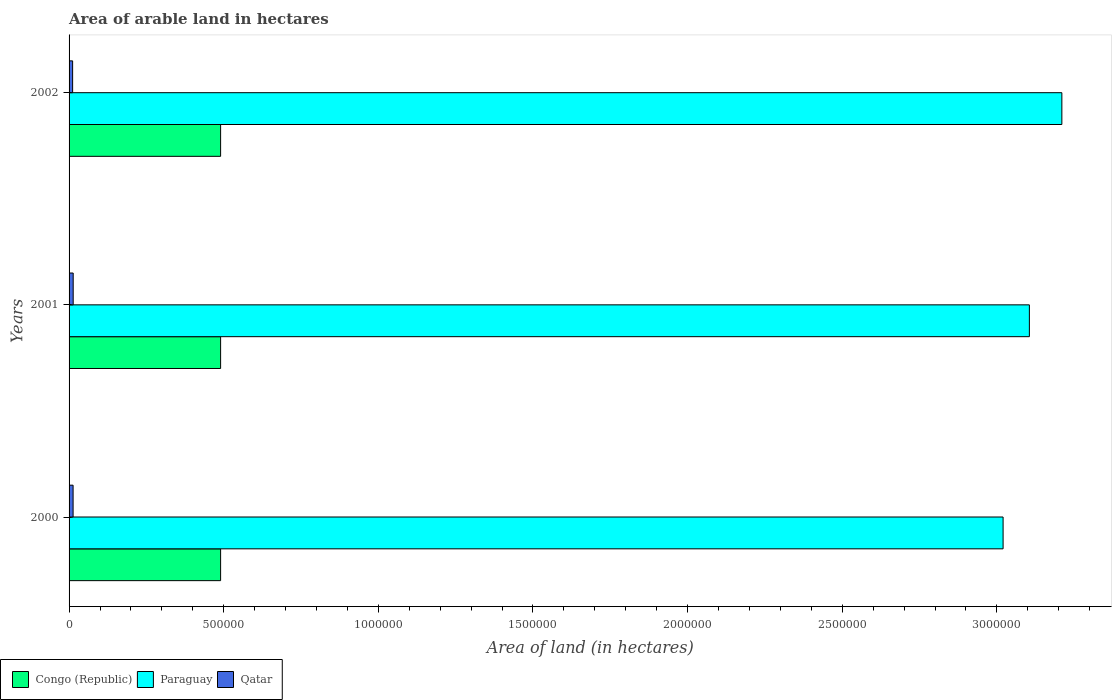How many bars are there on the 1st tick from the top?
Your response must be concise. 3. What is the total arable land in Qatar in 2001?
Ensure brevity in your answer.  1.33e+04. Across all years, what is the maximum total arable land in Paraguay?
Provide a succinct answer. 3.21e+06. Across all years, what is the minimum total arable land in Paraguay?
Your response must be concise. 3.02e+06. What is the total total arable land in Congo (Republic) in the graph?
Offer a terse response. 1.47e+06. What is the difference between the total arable land in Paraguay in 2000 and that in 2001?
Provide a short and direct response. -8.50e+04. What is the difference between the total arable land in Congo (Republic) in 2001 and the total arable land in Qatar in 2002?
Offer a very short reply. 4.78e+05. What is the average total arable land in Congo (Republic) per year?
Offer a terse response. 4.90e+05. In the year 2000, what is the difference between the total arable land in Paraguay and total arable land in Qatar?
Your answer should be compact. 3.01e+06. In how many years, is the total arable land in Congo (Republic) greater than 500000 hectares?
Your answer should be compact. 0. Is the total arable land in Paraguay in 2000 less than that in 2002?
Make the answer very short. Yes. Is the difference between the total arable land in Paraguay in 2001 and 2002 greater than the difference between the total arable land in Qatar in 2001 and 2002?
Keep it short and to the point. No. What is the difference between the highest and the second highest total arable land in Congo (Republic)?
Make the answer very short. 0. What is the difference between the highest and the lowest total arable land in Qatar?
Your answer should be very brief. 1800. Is the sum of the total arable land in Congo (Republic) in 2000 and 2001 greater than the maximum total arable land in Qatar across all years?
Give a very brief answer. Yes. What does the 1st bar from the top in 2000 represents?
Your answer should be compact. Qatar. What does the 2nd bar from the bottom in 2000 represents?
Your answer should be very brief. Paraguay. Is it the case that in every year, the sum of the total arable land in Congo (Republic) and total arable land in Qatar is greater than the total arable land in Paraguay?
Ensure brevity in your answer.  No. Does the graph contain any zero values?
Offer a terse response. No. How many legend labels are there?
Provide a short and direct response. 3. How are the legend labels stacked?
Make the answer very short. Horizontal. What is the title of the graph?
Give a very brief answer. Area of arable land in hectares. Does "Sub-Saharan Africa (developing only)" appear as one of the legend labels in the graph?
Offer a terse response. No. What is the label or title of the X-axis?
Provide a succinct answer. Area of land (in hectares). What is the label or title of the Y-axis?
Offer a very short reply. Years. What is the Area of land (in hectares) in Paraguay in 2000?
Provide a succinct answer. 3.02e+06. What is the Area of land (in hectares) in Qatar in 2000?
Ensure brevity in your answer.  1.30e+04. What is the Area of land (in hectares) of Congo (Republic) in 2001?
Ensure brevity in your answer.  4.90e+05. What is the Area of land (in hectares) of Paraguay in 2001?
Give a very brief answer. 3.10e+06. What is the Area of land (in hectares) in Qatar in 2001?
Your answer should be compact. 1.33e+04. What is the Area of land (in hectares) of Congo (Republic) in 2002?
Ensure brevity in your answer.  4.90e+05. What is the Area of land (in hectares) in Paraguay in 2002?
Ensure brevity in your answer.  3.21e+06. What is the Area of land (in hectares) of Qatar in 2002?
Offer a terse response. 1.15e+04. Across all years, what is the maximum Area of land (in hectares) of Congo (Republic)?
Offer a very short reply. 4.90e+05. Across all years, what is the maximum Area of land (in hectares) in Paraguay?
Offer a terse response. 3.21e+06. Across all years, what is the maximum Area of land (in hectares) of Qatar?
Offer a very short reply. 1.33e+04. Across all years, what is the minimum Area of land (in hectares) of Congo (Republic)?
Offer a very short reply. 4.90e+05. Across all years, what is the minimum Area of land (in hectares) in Paraguay?
Your answer should be compact. 3.02e+06. Across all years, what is the minimum Area of land (in hectares) in Qatar?
Your answer should be compact. 1.15e+04. What is the total Area of land (in hectares) in Congo (Republic) in the graph?
Provide a succinct answer. 1.47e+06. What is the total Area of land (in hectares) of Paraguay in the graph?
Keep it short and to the point. 9.34e+06. What is the total Area of land (in hectares) of Qatar in the graph?
Ensure brevity in your answer.  3.78e+04. What is the difference between the Area of land (in hectares) of Paraguay in 2000 and that in 2001?
Your answer should be compact. -8.50e+04. What is the difference between the Area of land (in hectares) in Qatar in 2000 and that in 2001?
Your response must be concise. -300. What is the difference between the Area of land (in hectares) of Congo (Republic) in 2000 and that in 2002?
Keep it short and to the point. 0. What is the difference between the Area of land (in hectares) of Paraguay in 2000 and that in 2002?
Your answer should be very brief. -1.90e+05. What is the difference between the Area of land (in hectares) of Qatar in 2000 and that in 2002?
Ensure brevity in your answer.  1500. What is the difference between the Area of land (in hectares) of Paraguay in 2001 and that in 2002?
Provide a succinct answer. -1.05e+05. What is the difference between the Area of land (in hectares) in Qatar in 2001 and that in 2002?
Your answer should be very brief. 1800. What is the difference between the Area of land (in hectares) in Congo (Republic) in 2000 and the Area of land (in hectares) in Paraguay in 2001?
Your answer should be very brief. -2.62e+06. What is the difference between the Area of land (in hectares) of Congo (Republic) in 2000 and the Area of land (in hectares) of Qatar in 2001?
Your answer should be very brief. 4.77e+05. What is the difference between the Area of land (in hectares) of Paraguay in 2000 and the Area of land (in hectares) of Qatar in 2001?
Provide a succinct answer. 3.01e+06. What is the difference between the Area of land (in hectares) of Congo (Republic) in 2000 and the Area of land (in hectares) of Paraguay in 2002?
Make the answer very short. -2.72e+06. What is the difference between the Area of land (in hectares) in Congo (Republic) in 2000 and the Area of land (in hectares) in Qatar in 2002?
Provide a short and direct response. 4.78e+05. What is the difference between the Area of land (in hectares) in Paraguay in 2000 and the Area of land (in hectares) in Qatar in 2002?
Your response must be concise. 3.01e+06. What is the difference between the Area of land (in hectares) in Congo (Republic) in 2001 and the Area of land (in hectares) in Paraguay in 2002?
Make the answer very short. -2.72e+06. What is the difference between the Area of land (in hectares) of Congo (Republic) in 2001 and the Area of land (in hectares) of Qatar in 2002?
Offer a terse response. 4.78e+05. What is the difference between the Area of land (in hectares) of Paraguay in 2001 and the Area of land (in hectares) of Qatar in 2002?
Offer a terse response. 3.09e+06. What is the average Area of land (in hectares) in Paraguay per year?
Make the answer very short. 3.11e+06. What is the average Area of land (in hectares) of Qatar per year?
Provide a succinct answer. 1.26e+04. In the year 2000, what is the difference between the Area of land (in hectares) in Congo (Republic) and Area of land (in hectares) in Paraguay?
Give a very brief answer. -2.53e+06. In the year 2000, what is the difference between the Area of land (in hectares) of Congo (Republic) and Area of land (in hectares) of Qatar?
Keep it short and to the point. 4.77e+05. In the year 2000, what is the difference between the Area of land (in hectares) in Paraguay and Area of land (in hectares) in Qatar?
Offer a terse response. 3.01e+06. In the year 2001, what is the difference between the Area of land (in hectares) in Congo (Republic) and Area of land (in hectares) in Paraguay?
Keep it short and to the point. -2.62e+06. In the year 2001, what is the difference between the Area of land (in hectares) of Congo (Republic) and Area of land (in hectares) of Qatar?
Provide a short and direct response. 4.77e+05. In the year 2001, what is the difference between the Area of land (in hectares) of Paraguay and Area of land (in hectares) of Qatar?
Provide a succinct answer. 3.09e+06. In the year 2002, what is the difference between the Area of land (in hectares) of Congo (Republic) and Area of land (in hectares) of Paraguay?
Give a very brief answer. -2.72e+06. In the year 2002, what is the difference between the Area of land (in hectares) in Congo (Republic) and Area of land (in hectares) in Qatar?
Make the answer very short. 4.78e+05. In the year 2002, what is the difference between the Area of land (in hectares) of Paraguay and Area of land (in hectares) of Qatar?
Provide a short and direct response. 3.20e+06. What is the ratio of the Area of land (in hectares) of Paraguay in 2000 to that in 2001?
Make the answer very short. 0.97. What is the ratio of the Area of land (in hectares) of Qatar in 2000 to that in 2001?
Give a very brief answer. 0.98. What is the ratio of the Area of land (in hectares) in Paraguay in 2000 to that in 2002?
Ensure brevity in your answer.  0.94. What is the ratio of the Area of land (in hectares) of Qatar in 2000 to that in 2002?
Provide a short and direct response. 1.13. What is the ratio of the Area of land (in hectares) in Congo (Republic) in 2001 to that in 2002?
Your response must be concise. 1. What is the ratio of the Area of land (in hectares) in Paraguay in 2001 to that in 2002?
Your answer should be very brief. 0.97. What is the ratio of the Area of land (in hectares) of Qatar in 2001 to that in 2002?
Keep it short and to the point. 1.16. What is the difference between the highest and the second highest Area of land (in hectares) in Congo (Republic)?
Make the answer very short. 0. What is the difference between the highest and the second highest Area of land (in hectares) in Paraguay?
Give a very brief answer. 1.05e+05. What is the difference between the highest and the second highest Area of land (in hectares) of Qatar?
Your answer should be very brief. 300. What is the difference between the highest and the lowest Area of land (in hectares) in Paraguay?
Your response must be concise. 1.90e+05. What is the difference between the highest and the lowest Area of land (in hectares) in Qatar?
Your response must be concise. 1800. 